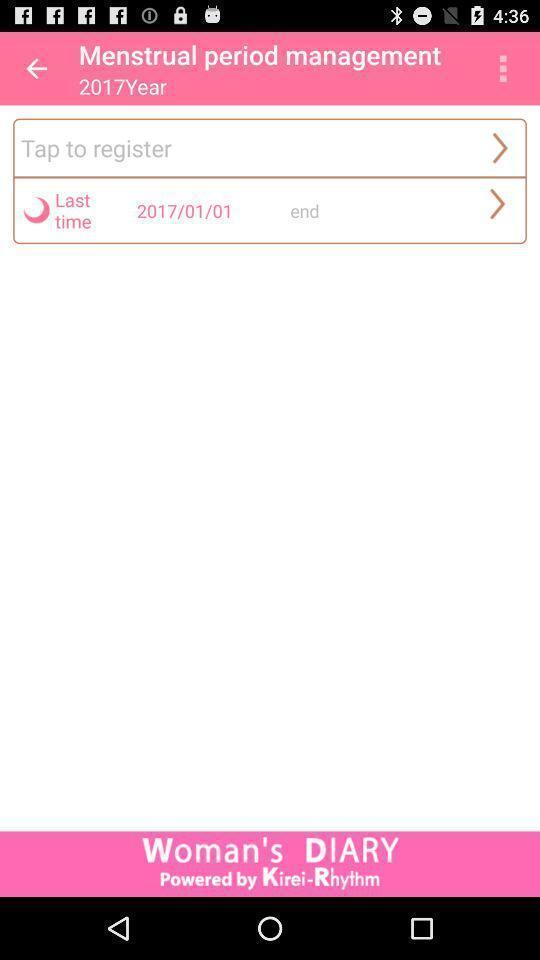Provide a description of this screenshot. Screen shows multiple options in a health application. 